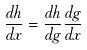Convert formula to latex. <formula><loc_0><loc_0><loc_500><loc_500>\frac { d h } { d x } = \frac { d h } { d g } \frac { d g } { d x }</formula> 